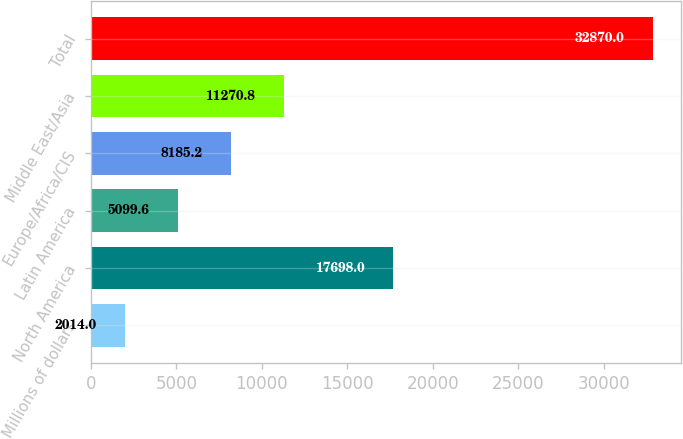Convert chart to OTSL. <chart><loc_0><loc_0><loc_500><loc_500><bar_chart><fcel>Millions of dollars<fcel>North America<fcel>Latin America<fcel>Europe/Africa/CIS<fcel>Middle East/Asia<fcel>Total<nl><fcel>2014<fcel>17698<fcel>5099.6<fcel>8185.2<fcel>11270.8<fcel>32870<nl></chart> 